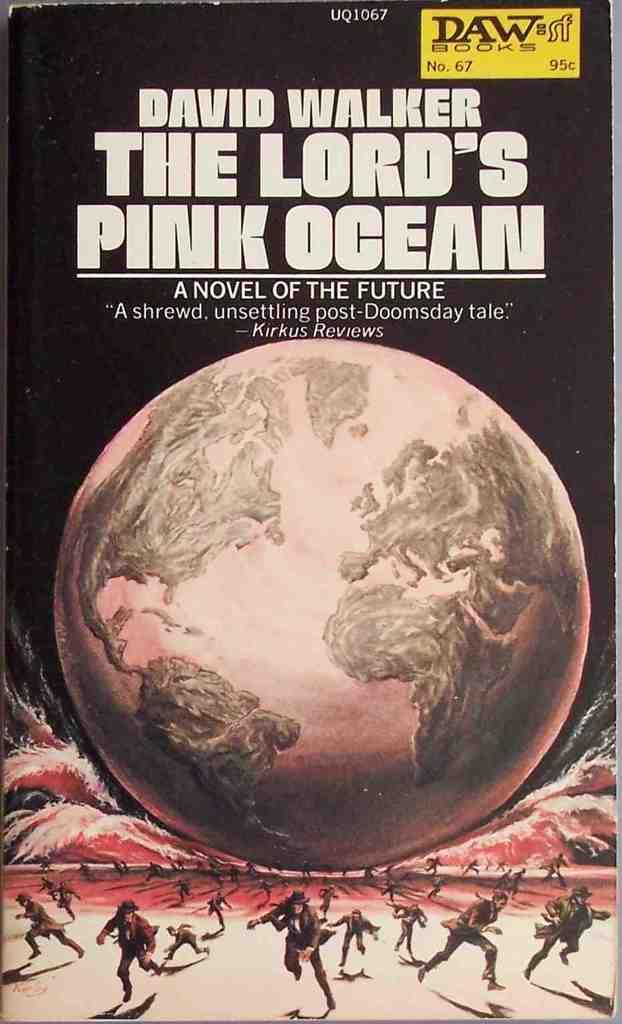<image>
Share a concise interpretation of the image provided. A novel by David Walker entitled the Lord's Pink Ocean. 